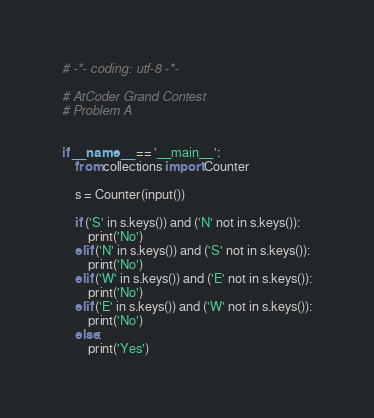<code> <loc_0><loc_0><loc_500><loc_500><_Python_># -*- coding: utf-8 -*-

# AtCoder Grand Contest
# Problem A


if __name__ == '__main__':
    from collections import Counter

    s = Counter(input())

    if ('S' in s.keys()) and ('N' not in s.keys()):
        print('No')
    elif ('N' in s.keys()) and ('S' not in s.keys()):
        print('No')
    elif ('W' in s.keys()) and ('E' not in s.keys()):
        print('No')
    elif ('E' in s.keys()) and ('W' not in s.keys()):
        print('No')
    else:
        print('Yes')
</code> 